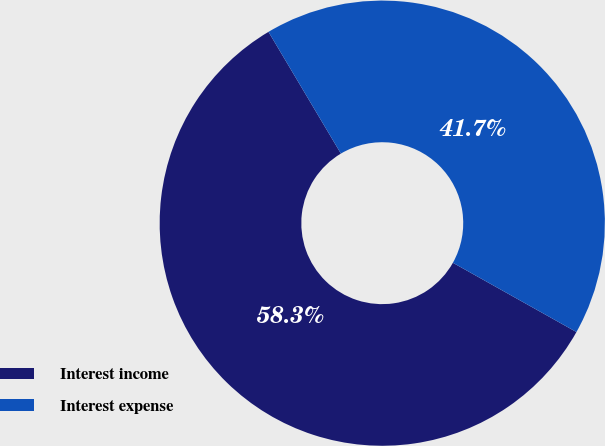Convert chart. <chart><loc_0><loc_0><loc_500><loc_500><pie_chart><fcel>Interest income<fcel>Interest expense<nl><fcel>58.33%<fcel>41.67%<nl></chart> 